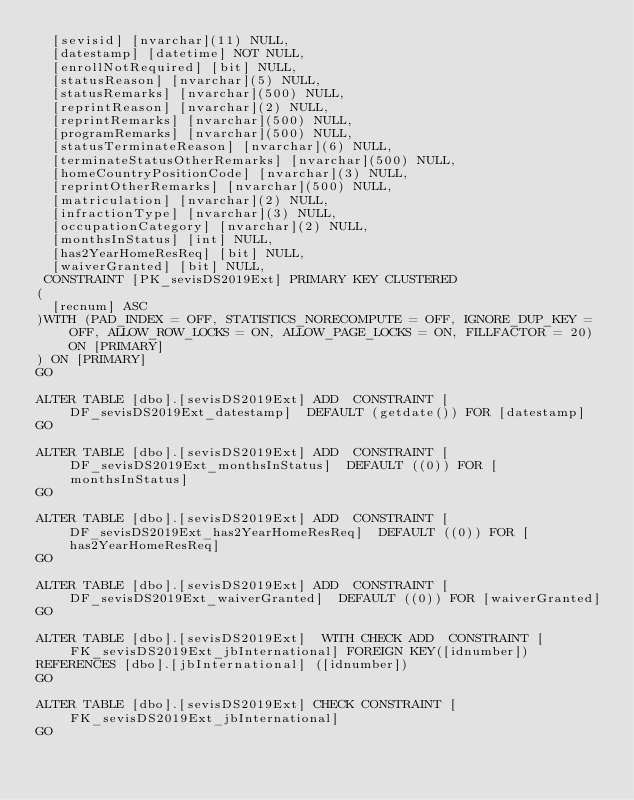<code> <loc_0><loc_0><loc_500><loc_500><_SQL_>	[sevisid] [nvarchar](11) NULL,
	[datestamp] [datetime] NOT NULL,
	[enrollNotRequired] [bit] NULL,
	[statusReason] [nvarchar](5) NULL,
	[statusRemarks] [nvarchar](500) NULL,
	[reprintReason] [nvarchar](2) NULL,
	[reprintRemarks] [nvarchar](500) NULL,
	[programRemarks] [nvarchar](500) NULL,
	[statusTerminateReason] [nvarchar](6) NULL,
	[terminateStatusOtherRemarks] [nvarchar](500) NULL,
	[homeCountryPositionCode] [nvarchar](3) NULL,
	[reprintOtherRemarks] [nvarchar](500) NULL,
	[matriculation] [nvarchar](2) NULL,
	[infractionType] [nvarchar](3) NULL,
	[occupationCategory] [nvarchar](2) NULL,
	[monthsInStatus] [int] NULL,
	[has2YearHomeResReq] [bit] NULL,
	[waiverGranted] [bit] NULL,
 CONSTRAINT [PK_sevisDS2019Ext] PRIMARY KEY CLUSTERED 
(
	[recnum] ASC
)WITH (PAD_INDEX = OFF, STATISTICS_NORECOMPUTE = OFF, IGNORE_DUP_KEY = OFF, ALLOW_ROW_LOCKS = ON, ALLOW_PAGE_LOCKS = ON, FILLFACTOR = 20) ON [PRIMARY]
) ON [PRIMARY]
GO

ALTER TABLE [dbo].[sevisDS2019Ext] ADD  CONSTRAINT [DF_sevisDS2019Ext_datestamp]  DEFAULT (getdate()) FOR [datestamp]
GO

ALTER TABLE [dbo].[sevisDS2019Ext] ADD  CONSTRAINT [DF_sevisDS2019Ext_monthsInStatus]  DEFAULT ((0)) FOR [monthsInStatus]
GO

ALTER TABLE [dbo].[sevisDS2019Ext] ADD  CONSTRAINT [DF_sevisDS2019Ext_has2YearHomeResReq]  DEFAULT ((0)) FOR [has2YearHomeResReq]
GO

ALTER TABLE [dbo].[sevisDS2019Ext] ADD  CONSTRAINT [DF_sevisDS2019Ext_waiverGranted]  DEFAULT ((0)) FOR [waiverGranted]
GO

ALTER TABLE [dbo].[sevisDS2019Ext]  WITH CHECK ADD  CONSTRAINT [FK_sevisDS2019Ext_jbInternational] FOREIGN KEY([idnumber])
REFERENCES [dbo].[jbInternational] ([idnumber])
GO

ALTER TABLE [dbo].[sevisDS2019Ext] CHECK CONSTRAINT [FK_sevisDS2019Ext_jbInternational]
GO


</code> 